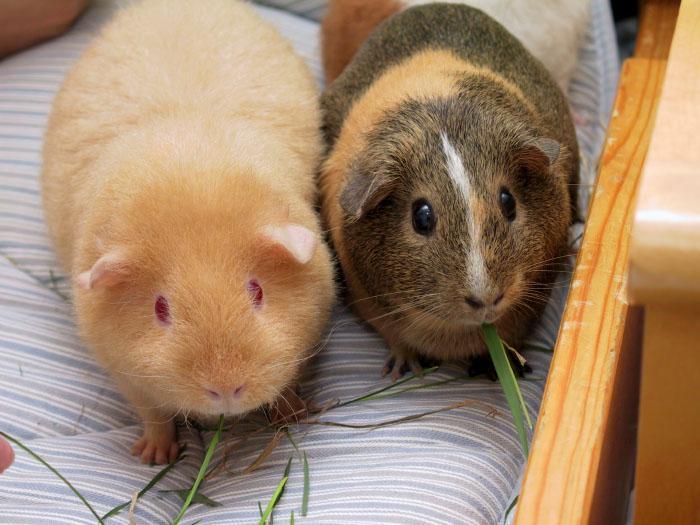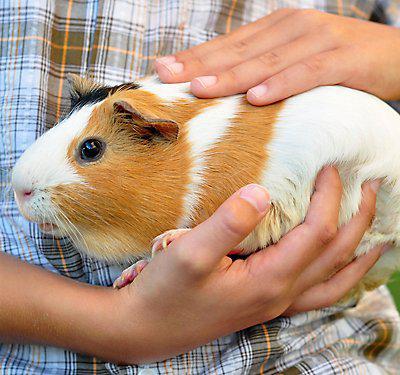The first image is the image on the left, the second image is the image on the right. Evaluate the accuracy of this statement regarding the images: "There are three guinea pigs". Is it true? Answer yes or no. Yes. 